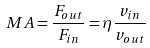<formula> <loc_0><loc_0><loc_500><loc_500>M A = { \frac { F _ { o u t } } { F _ { i n } } } = \eta { \frac { v _ { i n } } { v _ { o u t } } }</formula> 